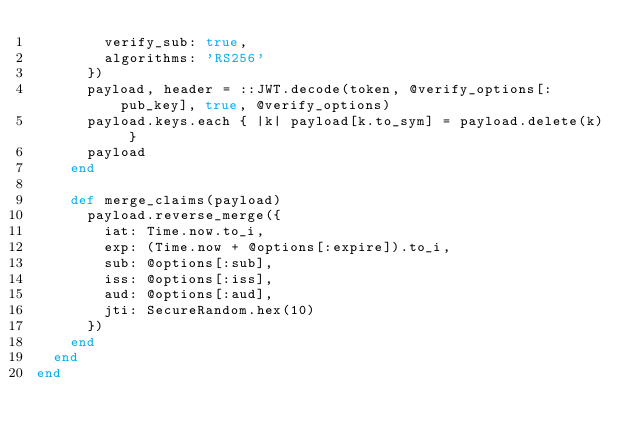<code> <loc_0><loc_0><loc_500><loc_500><_Ruby_>        verify_sub: true,
        algorithms: 'RS256'
      })
      payload, header = ::JWT.decode(token, @verify_options[:pub_key], true, @verify_options)
      payload.keys.each { |k| payload[k.to_sym] = payload.delete(k) }
      payload
    end

    def merge_claims(payload)
      payload.reverse_merge({
        iat: Time.now.to_i,
        exp: (Time.now + @options[:expire]).to_i,
        sub: @options[:sub],
        iss: @options[:iss],
        aud: @options[:aud],
        jti: SecureRandom.hex(10)
      })
    end
  end
end
</code> 